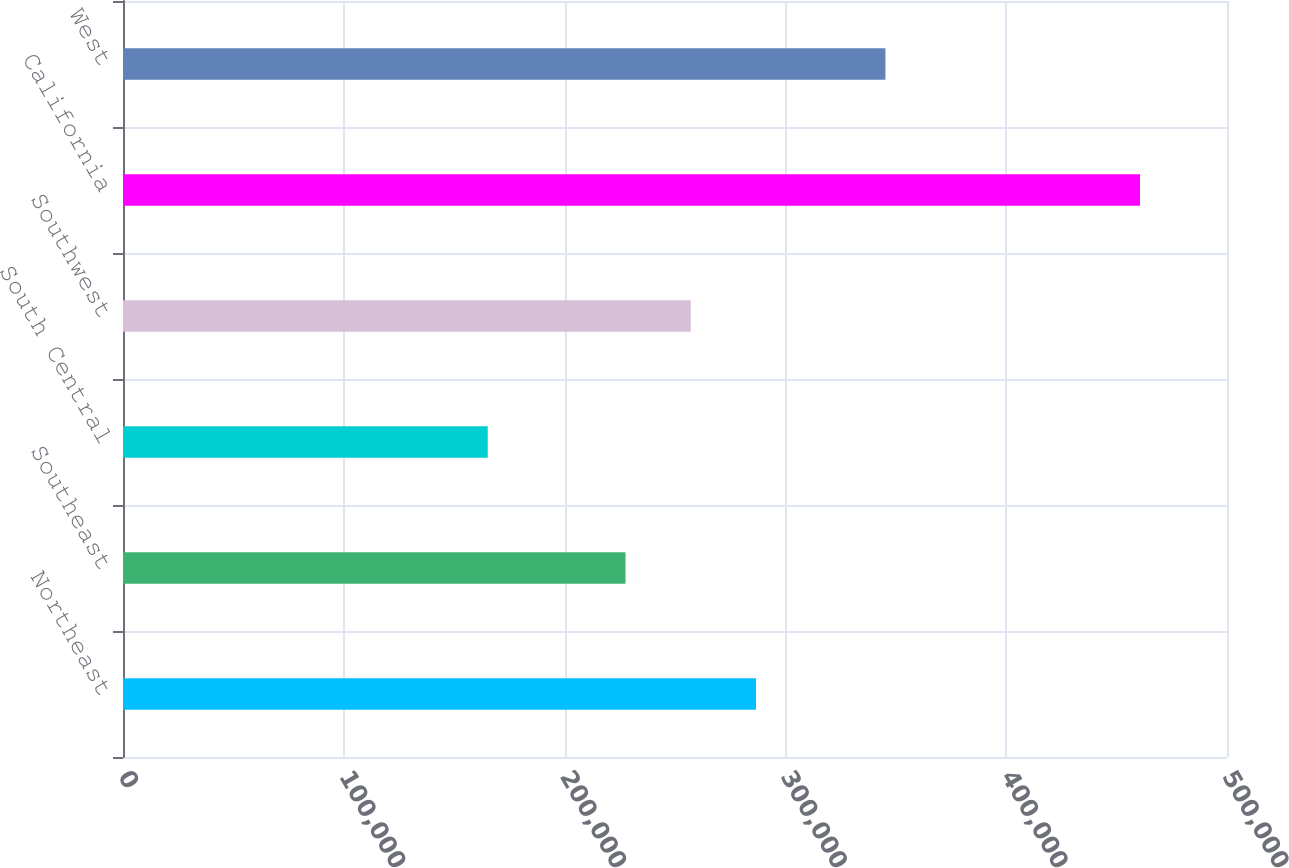<chart> <loc_0><loc_0><loc_500><loc_500><bar_chart><fcel>Northeast<fcel>Southeast<fcel>South Central<fcel>Southwest<fcel>California<fcel>West<nl><fcel>286680<fcel>227600<fcel>165200<fcel>257140<fcel>460600<fcel>345300<nl></chart> 